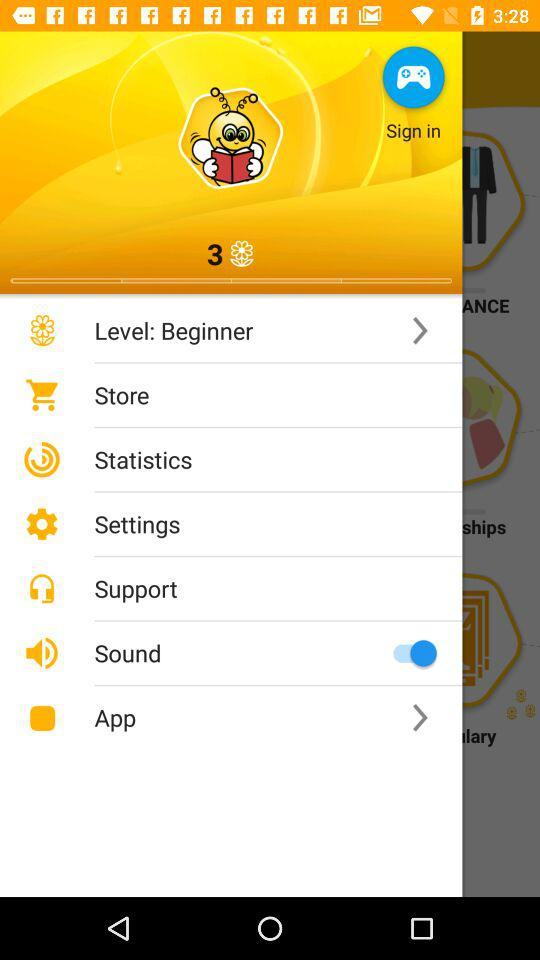Which language is selected? The selected language is English. 